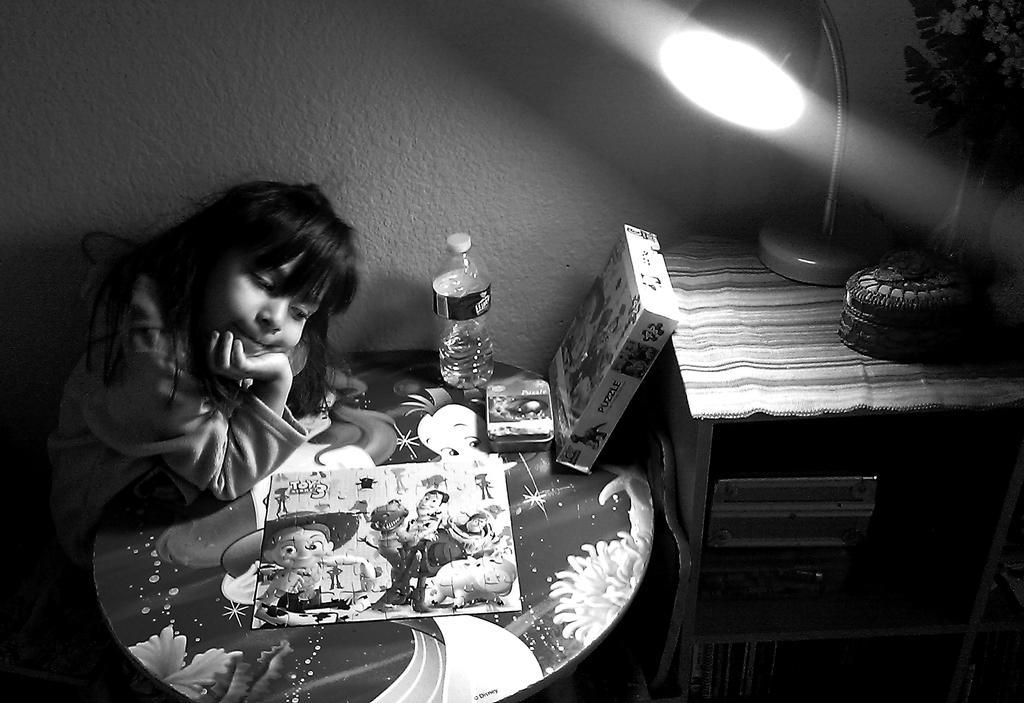How would you summarize this image in a sentence or two? In this picture we can see a girl who is sitting on the chair. This is the table, on the table there is a bottle, box, and a book. And this is box. Here we can see a lamp on the table and this is the cloth. And on the background there is a wall. 